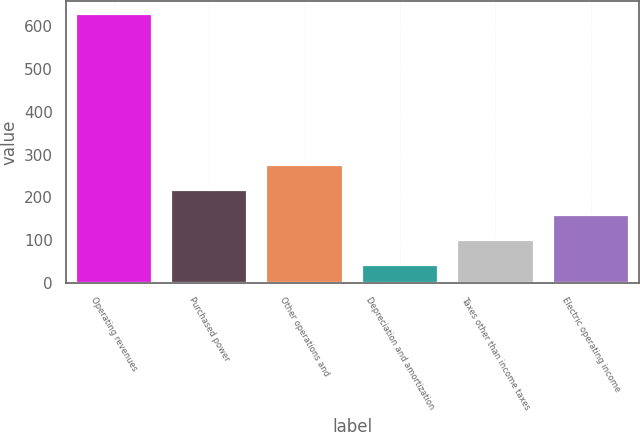Convert chart. <chart><loc_0><loc_0><loc_500><loc_500><bar_chart><fcel>Operating revenues<fcel>Purchased power<fcel>Other operations and<fcel>Depreciation and amortization<fcel>Taxes other than income taxes<fcel>Electric operating income<nl><fcel>628<fcel>217.1<fcel>275.8<fcel>41<fcel>99.7<fcel>158.4<nl></chart> 